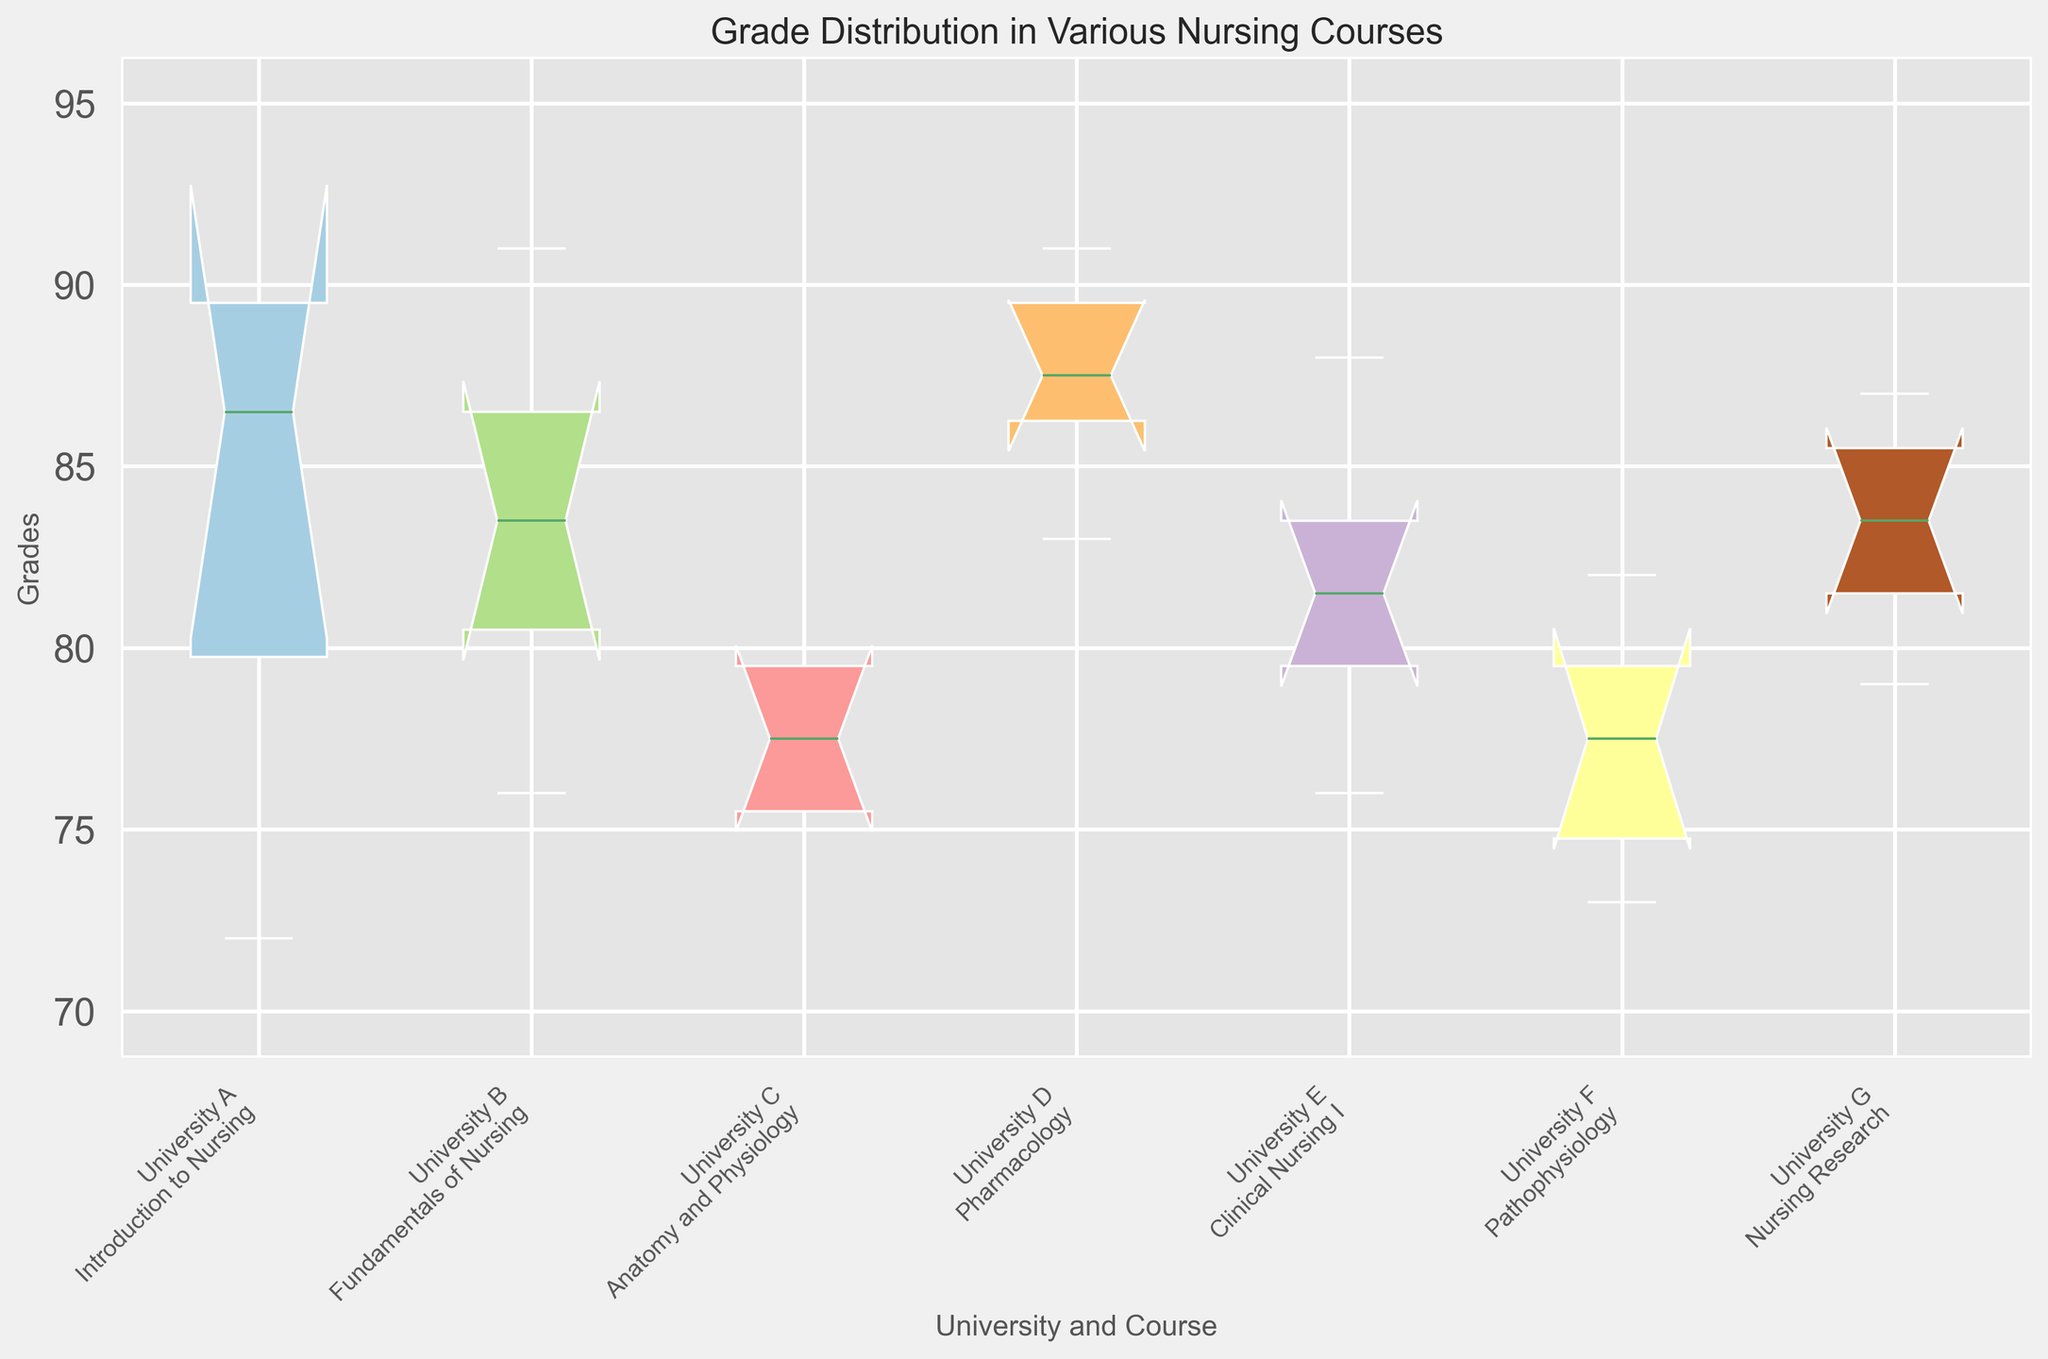What's the median grade for "Introduction to Nursing" at University A? To identify the median grade for "Introduction to Nursing" at University A, look at the central value of the box plot for this course. Since there are six grades (85, 78, 90, 72, 88, 95), arrange them in ascending order (72, 78, 85, 88, 90, 95). The median is the average of the two central numbers (85 and 88), which is (85 + 88)/2 = 86.5
Answer: 86.5 Which course and university combination shows the highest median grade? Look at the median line within each box plot. The median grade is visually represented by the line inside the box. The highest median line appears to be at "Pharmacology" from University D.
Answer: Pharmacology, University D What is the interquartile range (IQR) for "Fundamentals of Nursing" at University B? The IQR is the difference between the third quartile (Q3) and the first quartile (Q1) values in the box plot. For "Fundamentals of Nursing" at University B, visually inspect the box to find Q3 and Q1. If we estimate Q3 at around 87 and Q1 at around 80, the IQR is 87 - 80 = 7
Answer: 7 Which course has the widest range of grades? The range of grades is represented by the length of the whiskers in the box plot. The course with the widest range of grades will have the longest whiskers. Visually, "Anatomy and Physiology" from University C appears to have the widest range of grades.
Answer: Anatomy and Physiology, University C How does the median grade of "Clinical Nursing I" at University E compare with "Pathophysiology" at University F? Compare the median lines of both box plots. The median for "Clinical Nursing I" at University E seems to be higher than that for "Pathophysiology" at University F.
Answer: Clinical Nursing I is higher What is the median grade difference between "Introduction to Nursing" at University A and "Pharmacology" at University D? Identify the medians of both box plots. The median for "Introduction to Nursing" is approximately 86.5, and the median for "Pharmacology" is approximately 88. The difference is 88 - 86.5 = 1.5
Answer: 1.5 What is the lowest grade recorded on the box plot, and for which course and university is it? The lowest grade on the box plot is shown by the minimum whisker value. The lowest grade appears to be 70 for "Anatomy and Physiology" at University C.
Answer: 70, Anatomy and Physiology, University C 